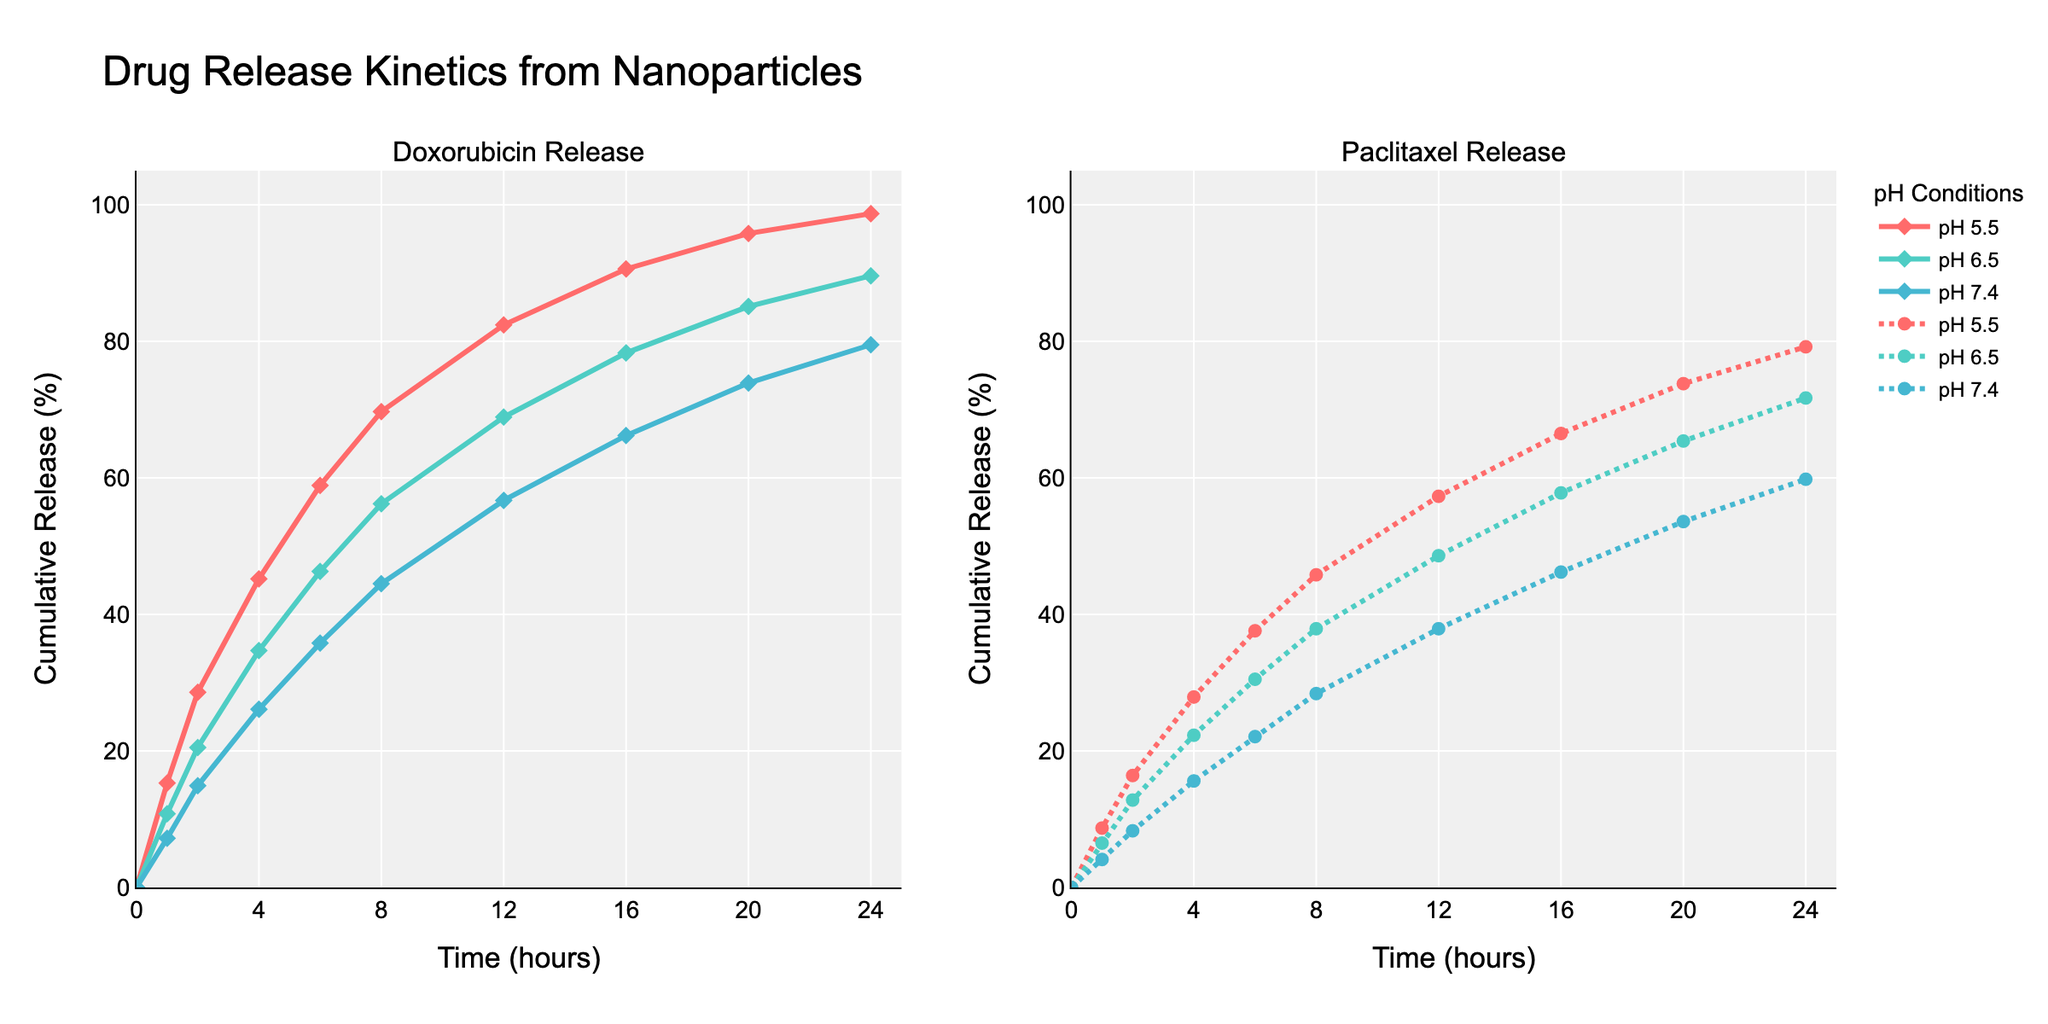What is the cumulative drug release of Doxorubicin at pH 5.5 after 8 hours? Look at the plot segment for Doxorubicin and identify the curve corresponding to pH 5.5. At the 8-hour mark, find the cumulative release percentage on the y-axis.
Answer: 69.7% Which drug shows a higher release rate at pH 6.5 after 12 hours, Doxorubicin or Paclitaxel? Compare the y-values at the 12-hour mark for both drugs at pH 6.5. The Doxorubicin release is 68.9%, and the Paclitaxel release is 48.6%.
Answer: Doxorubicin By how much does the cumulative release of Paclitaxel at pH 7.4 increase from 1 hour to 4 hours? For Paclitaxel at pH 7.4, note the cumulative release at 1 hour (4.1%) and at 4 hours (15.6%). Calculate the difference: 15.6% - 4.1%.
Answer: 11.5% What is the difference in cumulative release between Doxorubicin at pH 5.5 and Paclitaxel at pH 5.5 after 24 hours? Identify the y-values for both Doxorubicin and Paclitaxel at pH 5.5 at the 24-hour mark. Doxorubicin is at 98.7%, and Paclitaxel is at 79.2%. Calculate the difference: 98.7% - 79.2%.
Answer: 19.5% At which pH does Paclitaxel have the lowest release rate at the 6-hour mark? Compare the y-values for Paclitaxel at pH 5.5, 6.5, and 7.4 at the 6-hour mark. The values are 37.6%, 30.5%, and 22.1% respectively.
Answer: pH 7.4 At the 16-hour mark, what is the average cumulative release percentage for Doxorubicin across all pH levels? Find the cumulative release percentage for Doxorubicin at pH 5.5 (90.6%), pH 6.5 (78.3%), and pH 7.4 (66.2%) at 16 hours. Calculate the average: (90.6 + 78.3 + 66.2) / 3.
Answer: 78.37% Between the time intervals of 8 and 12 hours, which drug and pH condition combination shows the steepest increase in release rate? Calculate the increase for each drug and pH condition between 8 and 12 hours. For Doxorubicin: pH 5.5 (82.4%-69.7%=12.7%), pH 6.5 (68.9%-56.2%=12.7%), pH 7.4 (56.7%-44.5%=12.2%). For Paclitaxel: pH 5.5 (57.3%-45.8%=11.5%), pH 6.5 (48.6%-37.9%=10.7%), pH 7.4 (37.9%-28.4%=9.5%). The steepest increase is for Doxorubicin at pH 5.5 and 6.5.
Answer: Doxorubicin at pH 5.5 and 6.5 After 20 hours, does Doxorubicin's cumulative release at pH 7.4 exceed Paclitaxel's cumulative release at pH 5.5? Compare Doxorubicin's release at pH 7.4 after 20 hours (73.9%) with Paclitaxel's release at pH 5.5 after 20 hours (73.8%).
Answer: Yes What is the cumulative release percentage trend for Paclitaxel at pH 7.4 from 0 to 24 hours? Observe the curve for Paclitaxel at pH 7.4 over the 24-hour period. The cumulative release increases continuously from 0% at 0 hours to 59.8% at 24 hours.
Answer: Increasing trend Which drug exhibits a quicker initial release (up to 2 hours) at pH 5.5, Doxorubicin or Paclitaxel? Compare the cumulative release percentages at 2 hours for both drugs at pH 5.5. Doxorubicin is 28.6%, and Paclitaxel is 16.4%.
Answer: Doxorubicin 